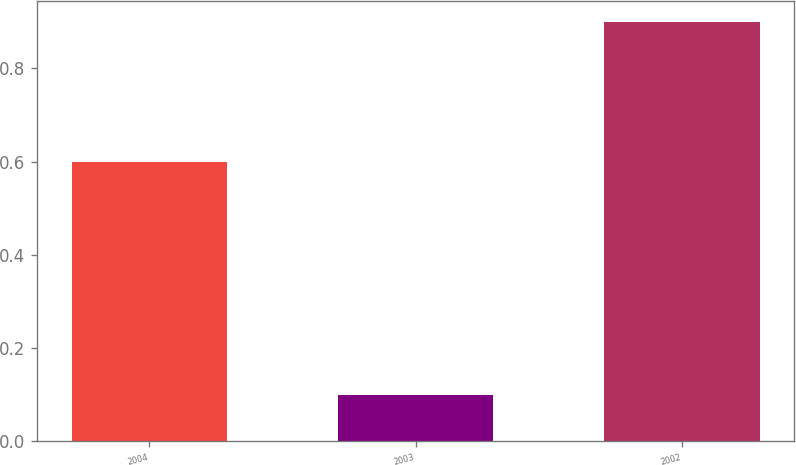Convert chart. <chart><loc_0><loc_0><loc_500><loc_500><bar_chart><fcel>2004<fcel>2003<fcel>2002<nl><fcel>0.6<fcel>0.1<fcel>0.9<nl></chart> 